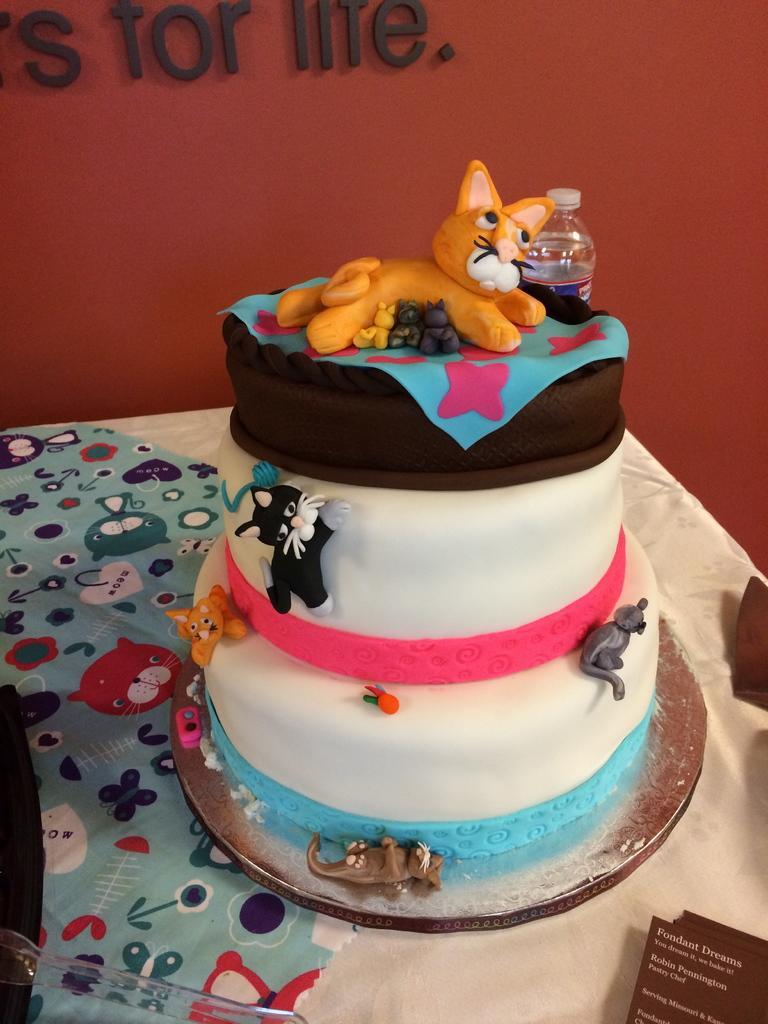In one or two sentences, can you explain what this image depicts? Here we can see three step cake with a cat doll on it placed on a table and we can see a bottle present and in the bottom left we can see a spoon and on the wall we can see something written 